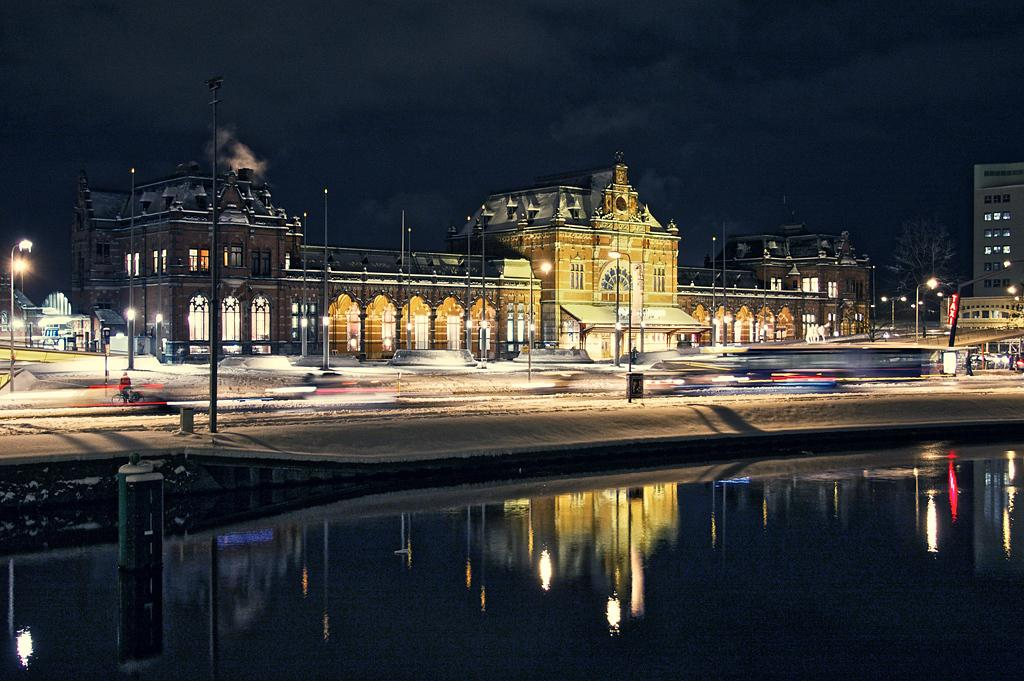What structures are present in the image? There are poles, lights, and buildings in the image. What type of vegetation is in the image? There is a tree in the image. What natural element is present in the image? There is water in the image. What is the condition of the water in the image? The water has a reflection in the image. What can be seen in the background of the image? There is sky visible in the background of the image. What is the main character's desire in the image? There is no main character or any indication of desires in the image; it features poles, lights, buildings, a tree, water, and sky. What decision does the tree make in the image? Trees do not make decisions; they are inanimate objects. 